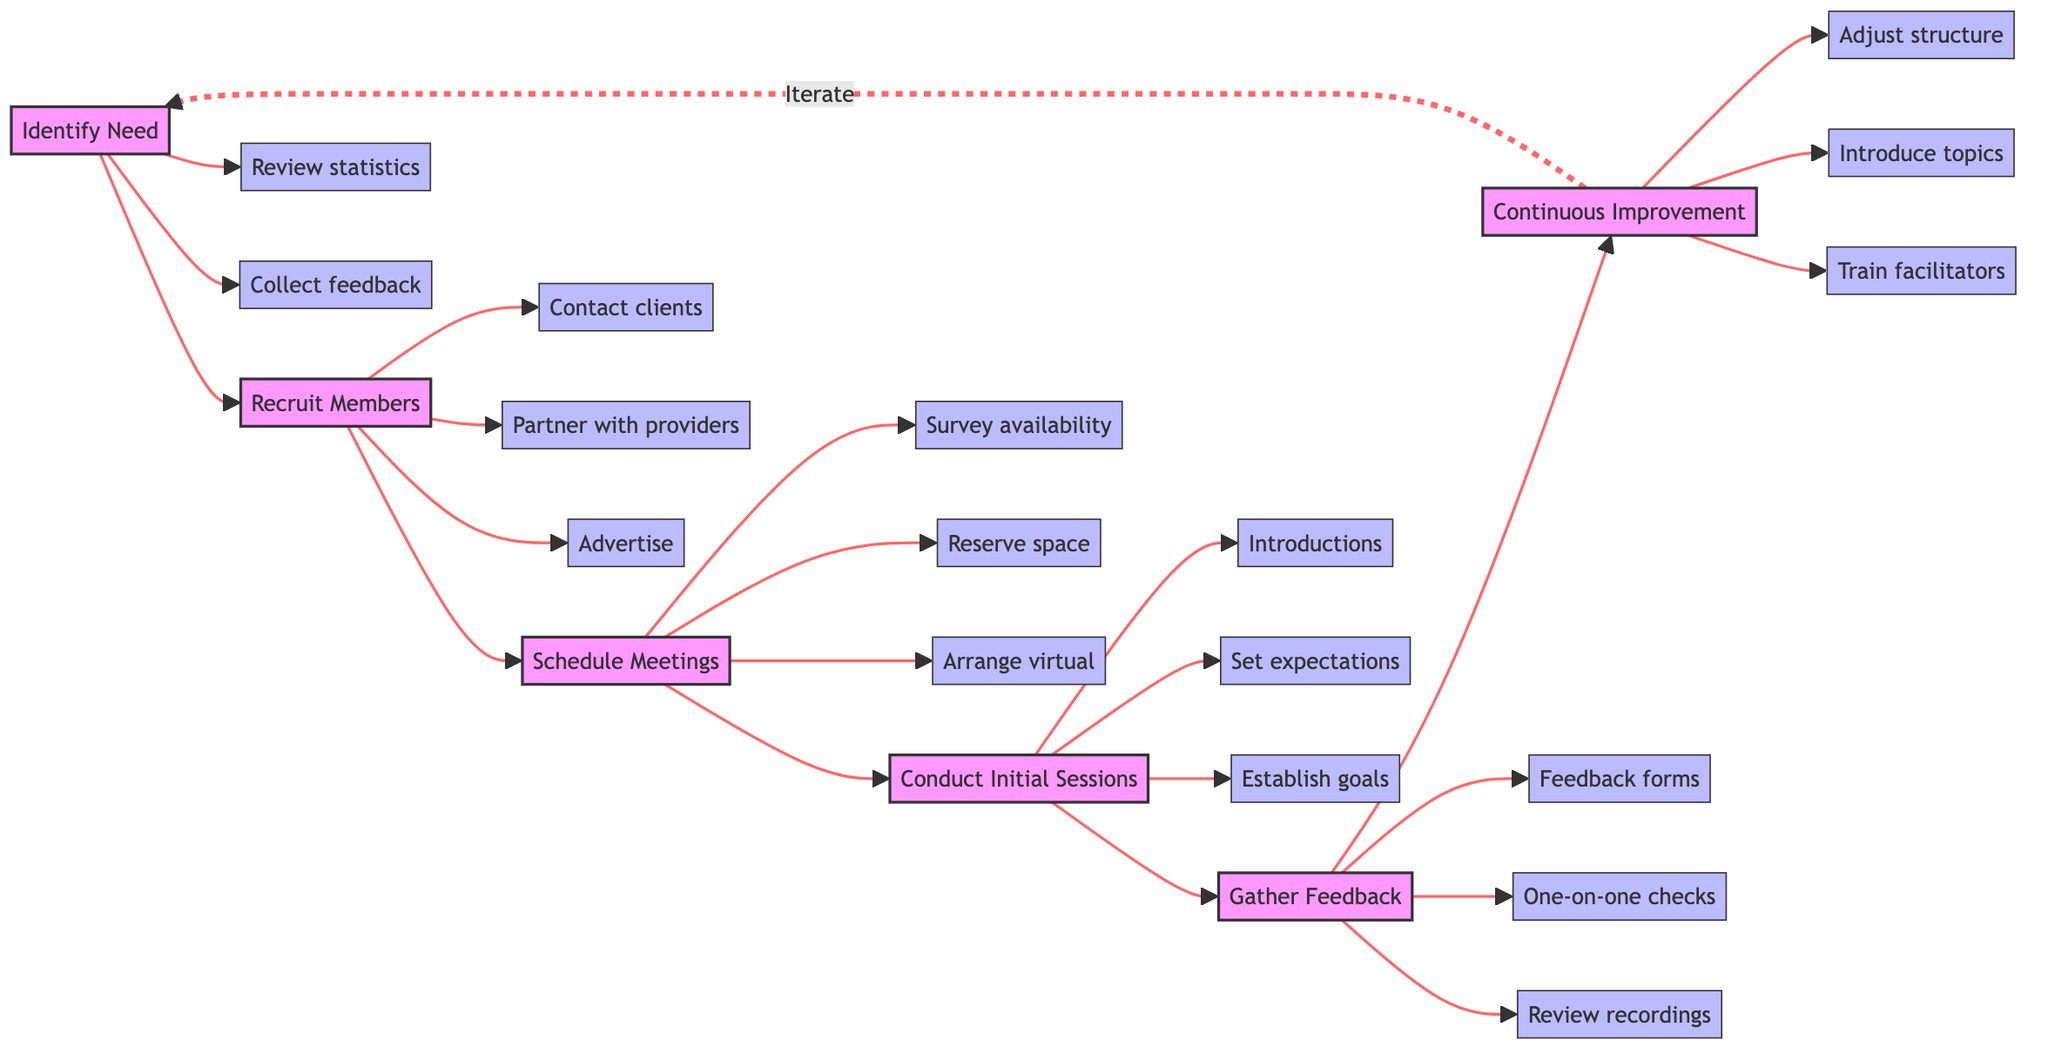What is the first stage in the flowchart? The flowchart begins with the stage labeled "Identify Need," which is the first node in the horizontal flow.
Answer: Identify Need How many total stages are there in the flowchart? By counting the distinct stages listed in the flowchart from "Identify Need" to "Continuous Improvement," there are six stages total.
Answer: 6 What actions are associated with the "Recruit Members" stage? The actions connected to the stage "Recruit Members" include contacting clients, partnering with providers, and advertising, which are listed as actions leading from this stage.
Answer: Contact clients, partner with providers, advertise Which stage comes before "Conduct Initial Sessions"? The stage that comes immediately before "Conduct Initial Sessions" in the flowchart is "Schedule Meetings," as it directly connects to the initial session stage.
Answer: Schedule Meetings What is the last stage in the horizontal flowchart? The final stage in the flowchart is "Continuous Improvement," which signifies the end of one cycle and emphasizes ongoing development based on feedback.
Answer: Continuous Improvement What action is linked to the "Gather Feedback" stage? The actions related to the "Gather Feedback" stage include distributing feedback forms, conducting one-on-one checks, and reviewing recordings, indicating the methods of gathering member feedback.
Answer: Distribute feedback forms, conduct one-on-one checks, review recordings How does the flow of the diagram indicate continuous improvement? The flowchart shows an iterative loop where "Continuous Improvement" leads back to "Identify Need," indicating a cycle where feedback and adjustments drive the ongoing development of the support group.
Answer: Iterate back to Identify Need What kind of meetings can be arranged according to "Schedule Meetings"? According to the "Schedule Meetings" stage, meetings can be in-person at a reserved space or virtual for remote participants, indicating flexibility in meeting formats.
Answer: In-person or virtual meetings 